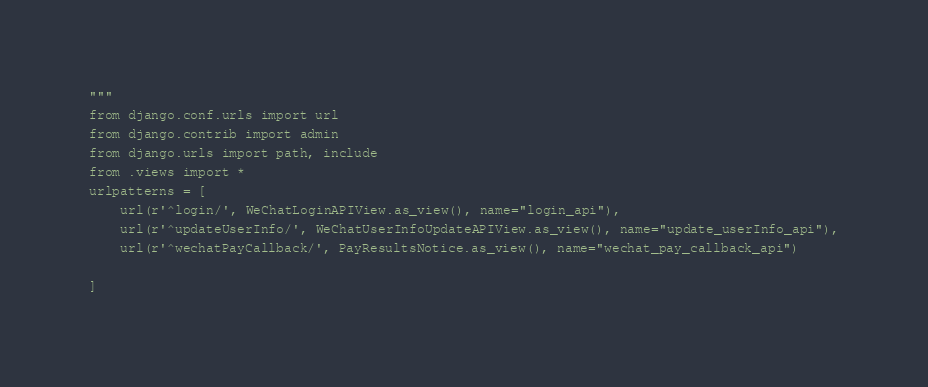Convert code to text. <code><loc_0><loc_0><loc_500><loc_500><_Python_>"""
from django.conf.urls import url
from django.contrib import admin
from django.urls import path, include
from .views import *
urlpatterns = [
    url(r'^login/', WeChatLoginAPIView.as_view(), name="login_api"),
    url(r'^updateUserInfo/', WeChatUserInfoUpdateAPIView.as_view(), name="update_userInfo_api"),
    url(r'^wechatPayCallback/', PayResultsNotice.as_view(), name="wechat_pay_callback_api")

]
</code> 